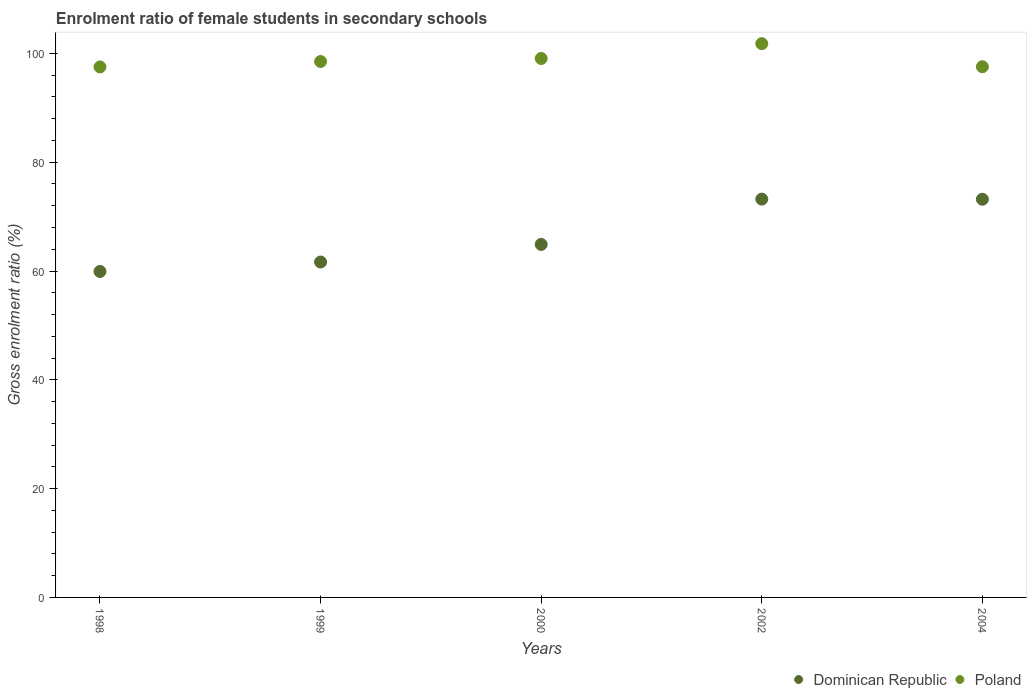How many different coloured dotlines are there?
Provide a short and direct response. 2. Is the number of dotlines equal to the number of legend labels?
Your answer should be compact. Yes. What is the enrolment ratio of female students in secondary schools in Dominican Republic in 2004?
Offer a terse response. 73.2. Across all years, what is the maximum enrolment ratio of female students in secondary schools in Dominican Republic?
Offer a very short reply. 73.22. Across all years, what is the minimum enrolment ratio of female students in secondary schools in Dominican Republic?
Offer a terse response. 59.92. In which year was the enrolment ratio of female students in secondary schools in Dominican Republic minimum?
Make the answer very short. 1998. What is the total enrolment ratio of female students in secondary schools in Dominican Republic in the graph?
Keep it short and to the point. 332.88. What is the difference between the enrolment ratio of female students in secondary schools in Poland in 2000 and that in 2004?
Make the answer very short. 1.51. What is the difference between the enrolment ratio of female students in secondary schools in Dominican Republic in 2002 and the enrolment ratio of female students in secondary schools in Poland in 2000?
Provide a succinct answer. -25.85. What is the average enrolment ratio of female students in secondary schools in Poland per year?
Make the answer very short. 98.89. In the year 2004, what is the difference between the enrolment ratio of female students in secondary schools in Dominican Republic and enrolment ratio of female students in secondary schools in Poland?
Make the answer very short. -24.36. In how many years, is the enrolment ratio of female students in secondary schools in Poland greater than 8 %?
Offer a very short reply. 5. What is the ratio of the enrolment ratio of female students in secondary schools in Poland in 2000 to that in 2002?
Keep it short and to the point. 0.97. What is the difference between the highest and the second highest enrolment ratio of female students in secondary schools in Dominican Republic?
Make the answer very short. 0.02. What is the difference between the highest and the lowest enrolment ratio of female students in secondary schools in Dominican Republic?
Give a very brief answer. 13.3. In how many years, is the enrolment ratio of female students in secondary schools in Poland greater than the average enrolment ratio of female students in secondary schools in Poland taken over all years?
Your answer should be compact. 2. Does the enrolment ratio of female students in secondary schools in Dominican Republic monotonically increase over the years?
Your response must be concise. No. Is the enrolment ratio of female students in secondary schools in Dominican Republic strictly greater than the enrolment ratio of female students in secondary schools in Poland over the years?
Offer a terse response. No. Is the enrolment ratio of female students in secondary schools in Dominican Republic strictly less than the enrolment ratio of female students in secondary schools in Poland over the years?
Make the answer very short. Yes. How many dotlines are there?
Provide a succinct answer. 2. What is the difference between two consecutive major ticks on the Y-axis?
Keep it short and to the point. 20. Does the graph contain grids?
Your response must be concise. No. Where does the legend appear in the graph?
Your answer should be very brief. Bottom right. What is the title of the graph?
Your answer should be compact. Enrolment ratio of female students in secondary schools. What is the label or title of the Y-axis?
Your answer should be compact. Gross enrolment ratio (%). What is the Gross enrolment ratio (%) in Dominican Republic in 1998?
Give a very brief answer. 59.92. What is the Gross enrolment ratio (%) of Poland in 1998?
Provide a succinct answer. 97.51. What is the Gross enrolment ratio (%) of Dominican Republic in 1999?
Ensure brevity in your answer.  61.66. What is the Gross enrolment ratio (%) in Poland in 1999?
Offer a terse response. 98.51. What is the Gross enrolment ratio (%) in Dominican Republic in 2000?
Provide a succinct answer. 64.89. What is the Gross enrolment ratio (%) in Poland in 2000?
Provide a short and direct response. 99.07. What is the Gross enrolment ratio (%) in Dominican Republic in 2002?
Offer a terse response. 73.22. What is the Gross enrolment ratio (%) in Poland in 2002?
Your answer should be very brief. 101.8. What is the Gross enrolment ratio (%) of Dominican Republic in 2004?
Make the answer very short. 73.2. What is the Gross enrolment ratio (%) of Poland in 2004?
Your answer should be very brief. 97.56. Across all years, what is the maximum Gross enrolment ratio (%) of Dominican Republic?
Make the answer very short. 73.22. Across all years, what is the maximum Gross enrolment ratio (%) in Poland?
Provide a succinct answer. 101.8. Across all years, what is the minimum Gross enrolment ratio (%) of Dominican Republic?
Give a very brief answer. 59.92. Across all years, what is the minimum Gross enrolment ratio (%) of Poland?
Ensure brevity in your answer.  97.51. What is the total Gross enrolment ratio (%) in Dominican Republic in the graph?
Your response must be concise. 332.88. What is the total Gross enrolment ratio (%) of Poland in the graph?
Keep it short and to the point. 494.45. What is the difference between the Gross enrolment ratio (%) of Dominican Republic in 1998 and that in 1999?
Offer a terse response. -1.74. What is the difference between the Gross enrolment ratio (%) in Poland in 1998 and that in 1999?
Your answer should be compact. -1. What is the difference between the Gross enrolment ratio (%) in Dominican Republic in 1998 and that in 2000?
Offer a terse response. -4.97. What is the difference between the Gross enrolment ratio (%) in Poland in 1998 and that in 2000?
Give a very brief answer. -1.56. What is the difference between the Gross enrolment ratio (%) of Dominican Republic in 1998 and that in 2002?
Your answer should be very brief. -13.3. What is the difference between the Gross enrolment ratio (%) of Poland in 1998 and that in 2002?
Your answer should be compact. -4.28. What is the difference between the Gross enrolment ratio (%) in Dominican Republic in 1998 and that in 2004?
Ensure brevity in your answer.  -13.28. What is the difference between the Gross enrolment ratio (%) in Poland in 1998 and that in 2004?
Make the answer very short. -0.04. What is the difference between the Gross enrolment ratio (%) of Dominican Republic in 1999 and that in 2000?
Provide a succinct answer. -3.23. What is the difference between the Gross enrolment ratio (%) of Poland in 1999 and that in 2000?
Provide a short and direct response. -0.55. What is the difference between the Gross enrolment ratio (%) of Dominican Republic in 1999 and that in 2002?
Your answer should be very brief. -11.56. What is the difference between the Gross enrolment ratio (%) in Poland in 1999 and that in 2002?
Offer a terse response. -3.28. What is the difference between the Gross enrolment ratio (%) in Dominican Republic in 1999 and that in 2004?
Ensure brevity in your answer.  -11.54. What is the difference between the Gross enrolment ratio (%) in Poland in 1999 and that in 2004?
Offer a very short reply. 0.96. What is the difference between the Gross enrolment ratio (%) of Dominican Republic in 2000 and that in 2002?
Give a very brief answer. -8.33. What is the difference between the Gross enrolment ratio (%) of Poland in 2000 and that in 2002?
Your answer should be very brief. -2.73. What is the difference between the Gross enrolment ratio (%) in Dominican Republic in 2000 and that in 2004?
Provide a succinct answer. -8.31. What is the difference between the Gross enrolment ratio (%) of Poland in 2000 and that in 2004?
Ensure brevity in your answer.  1.51. What is the difference between the Gross enrolment ratio (%) in Dominican Republic in 2002 and that in 2004?
Your answer should be very brief. 0.02. What is the difference between the Gross enrolment ratio (%) in Poland in 2002 and that in 2004?
Your response must be concise. 4.24. What is the difference between the Gross enrolment ratio (%) in Dominican Republic in 1998 and the Gross enrolment ratio (%) in Poland in 1999?
Make the answer very short. -38.6. What is the difference between the Gross enrolment ratio (%) in Dominican Republic in 1998 and the Gross enrolment ratio (%) in Poland in 2000?
Offer a terse response. -39.15. What is the difference between the Gross enrolment ratio (%) of Dominican Republic in 1998 and the Gross enrolment ratio (%) of Poland in 2002?
Offer a very short reply. -41.88. What is the difference between the Gross enrolment ratio (%) of Dominican Republic in 1998 and the Gross enrolment ratio (%) of Poland in 2004?
Ensure brevity in your answer.  -37.64. What is the difference between the Gross enrolment ratio (%) in Dominican Republic in 1999 and the Gross enrolment ratio (%) in Poland in 2000?
Offer a terse response. -37.41. What is the difference between the Gross enrolment ratio (%) in Dominican Republic in 1999 and the Gross enrolment ratio (%) in Poland in 2002?
Give a very brief answer. -40.14. What is the difference between the Gross enrolment ratio (%) of Dominican Republic in 1999 and the Gross enrolment ratio (%) of Poland in 2004?
Provide a succinct answer. -35.9. What is the difference between the Gross enrolment ratio (%) of Dominican Republic in 2000 and the Gross enrolment ratio (%) of Poland in 2002?
Your answer should be very brief. -36.91. What is the difference between the Gross enrolment ratio (%) in Dominican Republic in 2000 and the Gross enrolment ratio (%) in Poland in 2004?
Ensure brevity in your answer.  -32.67. What is the difference between the Gross enrolment ratio (%) of Dominican Republic in 2002 and the Gross enrolment ratio (%) of Poland in 2004?
Provide a short and direct response. -24.34. What is the average Gross enrolment ratio (%) in Dominican Republic per year?
Your answer should be compact. 66.58. What is the average Gross enrolment ratio (%) in Poland per year?
Give a very brief answer. 98.89. In the year 1998, what is the difference between the Gross enrolment ratio (%) in Dominican Republic and Gross enrolment ratio (%) in Poland?
Keep it short and to the point. -37.6. In the year 1999, what is the difference between the Gross enrolment ratio (%) in Dominican Republic and Gross enrolment ratio (%) in Poland?
Give a very brief answer. -36.86. In the year 2000, what is the difference between the Gross enrolment ratio (%) of Dominican Republic and Gross enrolment ratio (%) of Poland?
Your answer should be compact. -34.18. In the year 2002, what is the difference between the Gross enrolment ratio (%) in Dominican Republic and Gross enrolment ratio (%) in Poland?
Your response must be concise. -28.58. In the year 2004, what is the difference between the Gross enrolment ratio (%) in Dominican Republic and Gross enrolment ratio (%) in Poland?
Keep it short and to the point. -24.36. What is the ratio of the Gross enrolment ratio (%) of Dominican Republic in 1998 to that in 1999?
Your response must be concise. 0.97. What is the ratio of the Gross enrolment ratio (%) in Poland in 1998 to that in 1999?
Your answer should be very brief. 0.99. What is the ratio of the Gross enrolment ratio (%) in Dominican Republic in 1998 to that in 2000?
Make the answer very short. 0.92. What is the ratio of the Gross enrolment ratio (%) of Poland in 1998 to that in 2000?
Your answer should be very brief. 0.98. What is the ratio of the Gross enrolment ratio (%) of Dominican Republic in 1998 to that in 2002?
Offer a terse response. 0.82. What is the ratio of the Gross enrolment ratio (%) in Poland in 1998 to that in 2002?
Provide a short and direct response. 0.96. What is the ratio of the Gross enrolment ratio (%) in Dominican Republic in 1998 to that in 2004?
Offer a very short reply. 0.82. What is the ratio of the Gross enrolment ratio (%) of Dominican Republic in 1999 to that in 2000?
Keep it short and to the point. 0.95. What is the ratio of the Gross enrolment ratio (%) in Dominican Republic in 1999 to that in 2002?
Your answer should be very brief. 0.84. What is the ratio of the Gross enrolment ratio (%) of Poland in 1999 to that in 2002?
Your response must be concise. 0.97. What is the ratio of the Gross enrolment ratio (%) of Dominican Republic in 1999 to that in 2004?
Provide a short and direct response. 0.84. What is the ratio of the Gross enrolment ratio (%) of Poland in 1999 to that in 2004?
Your answer should be compact. 1.01. What is the ratio of the Gross enrolment ratio (%) in Dominican Republic in 2000 to that in 2002?
Provide a short and direct response. 0.89. What is the ratio of the Gross enrolment ratio (%) of Poland in 2000 to that in 2002?
Provide a short and direct response. 0.97. What is the ratio of the Gross enrolment ratio (%) of Dominican Republic in 2000 to that in 2004?
Offer a terse response. 0.89. What is the ratio of the Gross enrolment ratio (%) of Poland in 2000 to that in 2004?
Give a very brief answer. 1.02. What is the ratio of the Gross enrolment ratio (%) of Poland in 2002 to that in 2004?
Your response must be concise. 1.04. What is the difference between the highest and the second highest Gross enrolment ratio (%) in Dominican Republic?
Make the answer very short. 0.02. What is the difference between the highest and the second highest Gross enrolment ratio (%) of Poland?
Give a very brief answer. 2.73. What is the difference between the highest and the lowest Gross enrolment ratio (%) of Dominican Republic?
Offer a terse response. 13.3. What is the difference between the highest and the lowest Gross enrolment ratio (%) of Poland?
Ensure brevity in your answer.  4.28. 